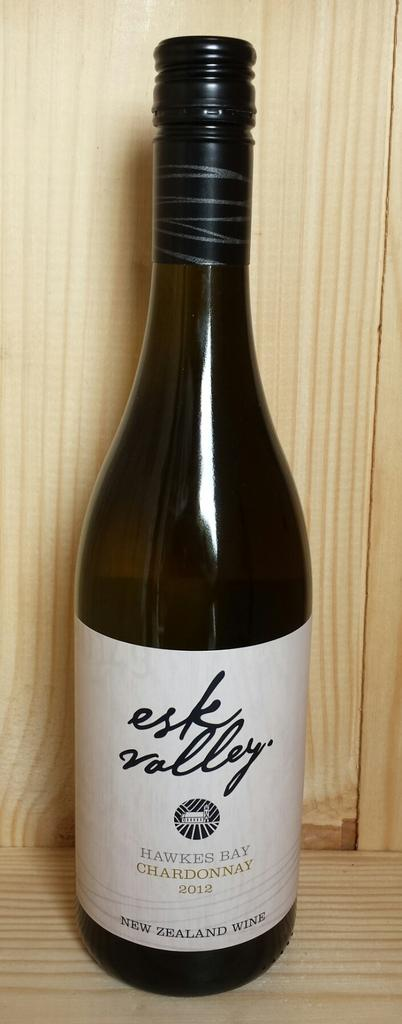<image>
Describe the image concisely. A bottle of chardonnay is labeled with the year 2012. 